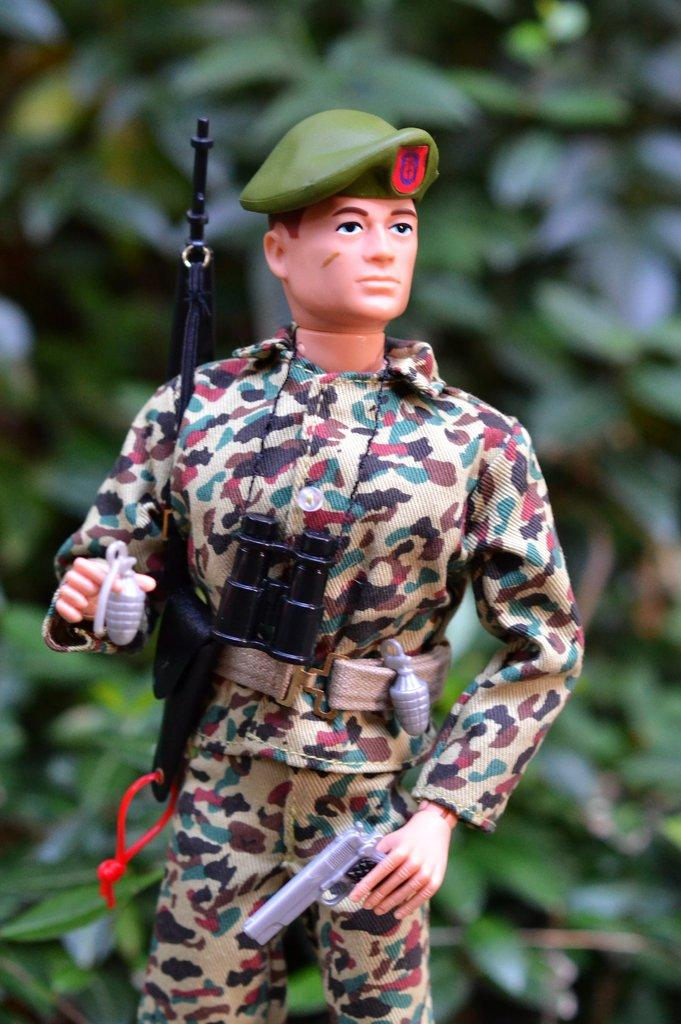What is the main subject of the image? The main subject of the image is a toy of a man. Can you describe the toy in the image? The toy is of a man, but no specific details about the toy's appearance or design are provided. What type of oil is being used to lubricate the toy's joints in the image? There is no mention of oil or any mechanical parts in the image, as it only features a toy of a man. 